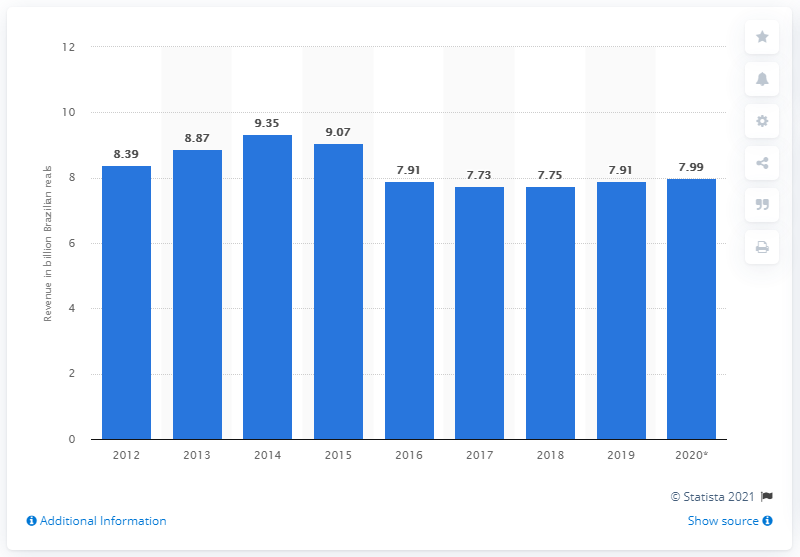Highlight a few significant elements in this photo. The expected revenue from Carnival in 2020 was 7.99. According to estimates, Carnival contributed 7.91 billion Brazilian reals to the Brazilian economy in 2019. 